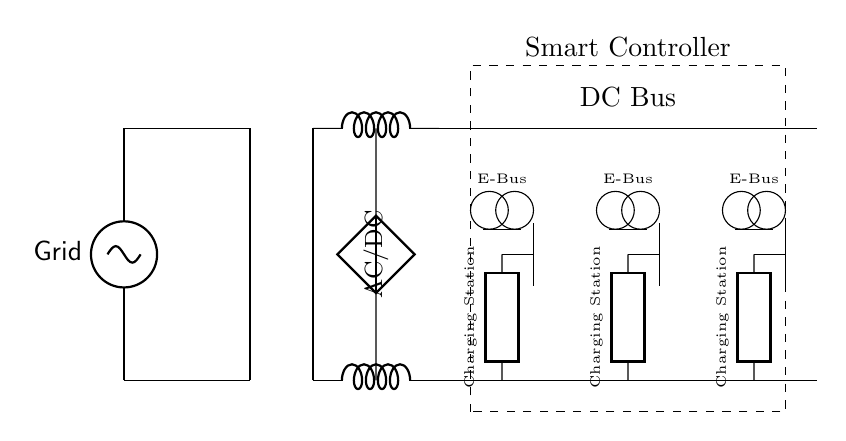What is the power source in this circuit? The power source is the grid, represented by the voltage source at the left side of the circuit diagram.
Answer: Grid How many charging stations are present in the circuit? There are three charging stations, as indicated by the three identical components labeled "Charging Station."
Answer: Three What component converts AC to DC? The component labeled "AC/DC" is responsible for converting alternating current to direct current, denoted by the placement and label near the converter in the circuit.
Answer: AC/DC What is the output connection of the transformer? The transformer provides a connection to both the AC and DC sides of the circuit, transitioning from the grid voltage to the input for the AC/DC converter.
Answer: To AC/DC converter What is the role of the smart controller in the circuit? The smart controller manages the overall operation of the charging network, ensuring optimal charging for the electric buses connected to the system.
Answer: Management What type of buses are represented in the circuit? The circuit includes electric buses, clearly marked as "E-Bus" in the upper section of the diagram, indicating their purpose in the transportation fleet.
Answer: Electric How is the DC bus structured in the circuit? The DC bus is shown as parallel lines connecting the outputs from the charging stations, which distributes power to all connected loads, including the electric buses.
Answer: Parallel connection 